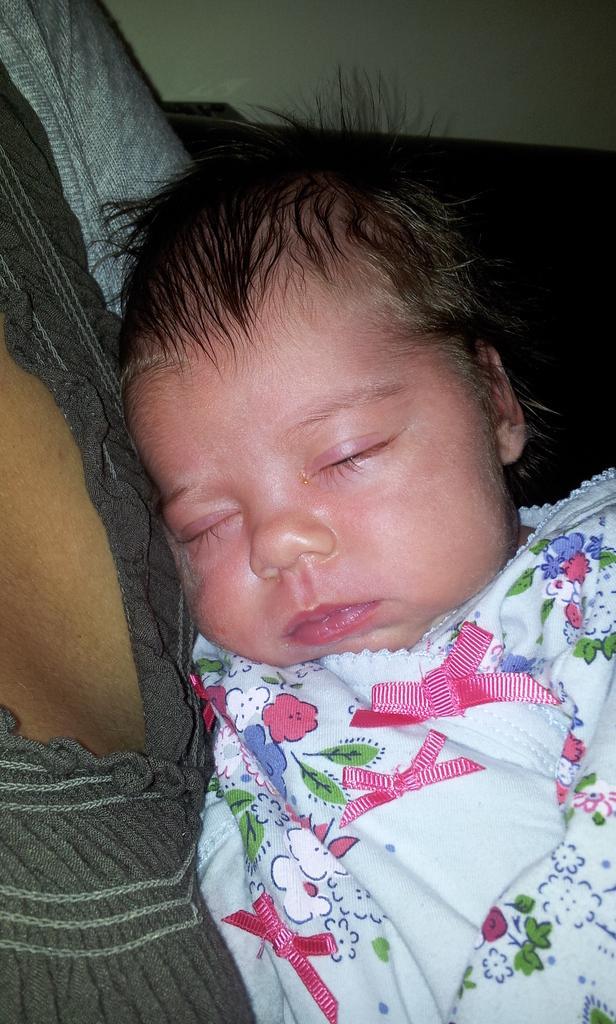Can you describe this image briefly? In this image I can see a baby and the person with the dresses. I can see the white and black background. 